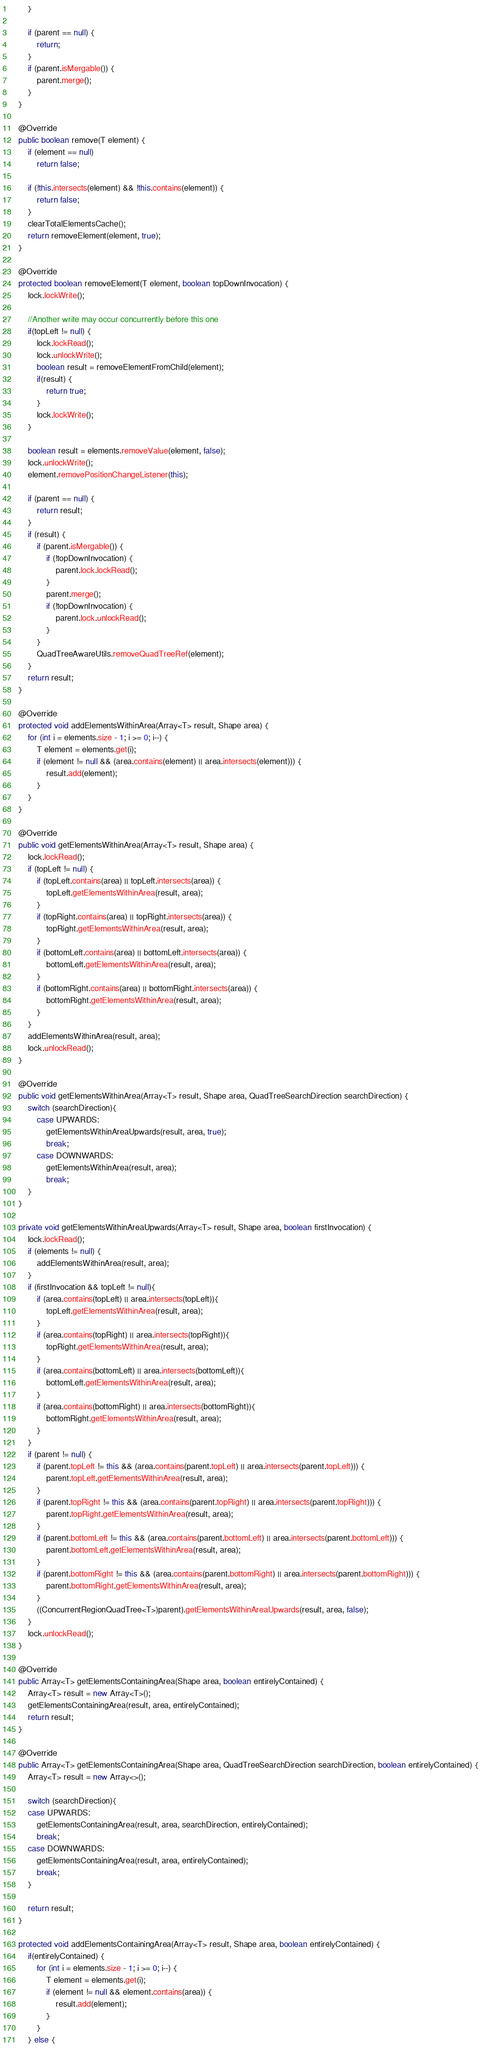<code> <loc_0><loc_0><loc_500><loc_500><_Java_>		}
		
		if (parent == null) {
			return;
		}
		if (parent.isMergable()) {
			parent.merge();
		}
	}

	@Override
	public boolean remove(T element) {
		if (element == null)
			return false;

		if (!this.intersects(element) && !this.contains(element)) {
			return false;
		}
		clearTotalElementsCache();
		return removeElement(element, true);
	}
	
	@Override
	protected boolean removeElement(T element, boolean topDownInvocation) {
		lock.lockWrite();
		
		//Another write may occur concurrently before this one
		if(topLeft != null) {
			lock.lockRead();
			lock.unlockWrite();
			boolean result = removeElementFromChild(element);
			if(result) {
				return true;
			}
			lock.lockWrite();
		}
		
		boolean result = elements.removeValue(element, false);
		lock.unlockWrite();
		element.removePositionChangeListener(this);

		if (parent == null) {
			return result;
		}
		if (result) {
			if (parent.isMergable()) {
				if (!topDownInvocation) {
					parent.lock.lockRead();
				}
				parent.merge();
				if (!topDownInvocation) {
					parent.lock.unlockRead();
				}
			}
			QuadTreeAwareUtils.removeQuadTreeRef(element);
		}
		return result;
	}

	@Override
	protected void addElementsWithinArea(Array<T> result, Shape area) {
		for (int i = elements.size - 1; i >= 0; i--) {
			T element = elements.get(i);
			if (element != null && (area.contains(element) || area.intersects(element))) {
				result.add(element);
			}
		}
	}

	@Override
	public void getElementsWithinArea(Array<T> result, Shape area) {
		lock.lockRead();
		if (topLeft != null) {
			if (topLeft.contains(area) || topLeft.intersects(area)) {
				topLeft.getElementsWithinArea(result, area);
			}
			if (topRight.contains(area) || topRight.intersects(area)) {
				topRight.getElementsWithinArea(result, area);
			}
			if (bottomLeft.contains(area) || bottomLeft.intersects(area)) {
				bottomLeft.getElementsWithinArea(result, area);
			}
			if (bottomRight.contains(area) || bottomRight.intersects(area)) {
				bottomRight.getElementsWithinArea(result, area);
			}
		}
		addElementsWithinArea(result, area);
		lock.unlockRead();
	}

	@Override
	public void getElementsWithinArea(Array<T> result, Shape area, QuadTreeSearchDirection searchDirection) {
		switch (searchDirection){
			case UPWARDS:
				getElementsWithinAreaUpwards(result, area, true);
				break;
			case DOWNWARDS:
				getElementsWithinArea(result, area);
				break;
		}
	}

	private void getElementsWithinAreaUpwards(Array<T> result, Shape area, boolean firstInvocation) {
		lock.lockRead();
		if (elements != null) {
			addElementsWithinArea(result, area);
		}
		if (firstInvocation && topLeft != null){
			if (area.contains(topLeft) || area.intersects(topLeft)){
				topLeft.getElementsWithinArea(result, area);
			}
			if (area.contains(topRight) || area.intersects(topRight)){
				topRight.getElementsWithinArea(result, area);
			}
			if (area.contains(bottomLeft) || area.intersects(bottomLeft)){
				bottomLeft.getElementsWithinArea(result, area);
			}
			if (area.contains(bottomRight) || area.intersects(bottomRight)){
				bottomRight.getElementsWithinArea(result, area);
			}
		}
		if (parent != null) {
			if (parent.topLeft != this && (area.contains(parent.topLeft) || area.intersects(parent.topLeft))) {
				parent.topLeft.getElementsWithinArea(result, area);
			}
			if (parent.topRight != this && (area.contains(parent.topRight) || area.intersects(parent.topRight))) {
				parent.topRight.getElementsWithinArea(result, area);
			}
			if (parent.bottomLeft != this && (area.contains(parent.bottomLeft) || area.intersects(parent.bottomLeft))) {
				parent.bottomLeft.getElementsWithinArea(result, area);
			}
			if (parent.bottomRight != this && (area.contains(parent.bottomRight) || area.intersects(parent.bottomRight))) {
				parent.bottomRight.getElementsWithinArea(result, area);
			}
			((ConcurrentRegionQuadTree<T>)parent).getElementsWithinAreaUpwards(result, area, false);
		}
		lock.unlockRead();
	}

	@Override
	public Array<T> getElementsContainingArea(Shape area, boolean entirelyContained) {
		Array<T> result = new Array<T>();
		getElementsContainingArea(result, area, entirelyContained);
		return result;
	}

	@Override
	public Array<T> getElementsContainingArea(Shape area, QuadTreeSearchDirection searchDirection, boolean entirelyContained) {
		Array<T> result = new Array<>();

		switch (searchDirection){
		case UPWARDS:
			getElementsContainingArea(result, area, searchDirection, entirelyContained);
			break;
		case DOWNWARDS:
			getElementsContainingArea(result, area, entirelyContained);
			break;
		}

		return result;
	}

	protected void addElementsContainingArea(Array<T> result, Shape area, boolean entirelyContained) {
		if(entirelyContained) {
			for (int i = elements.size - 1; i >= 0; i--) {
				T element = elements.get(i);
				if (element != null && element.contains(area)) {
					result.add(element);
				}
			}
		} else {</code> 